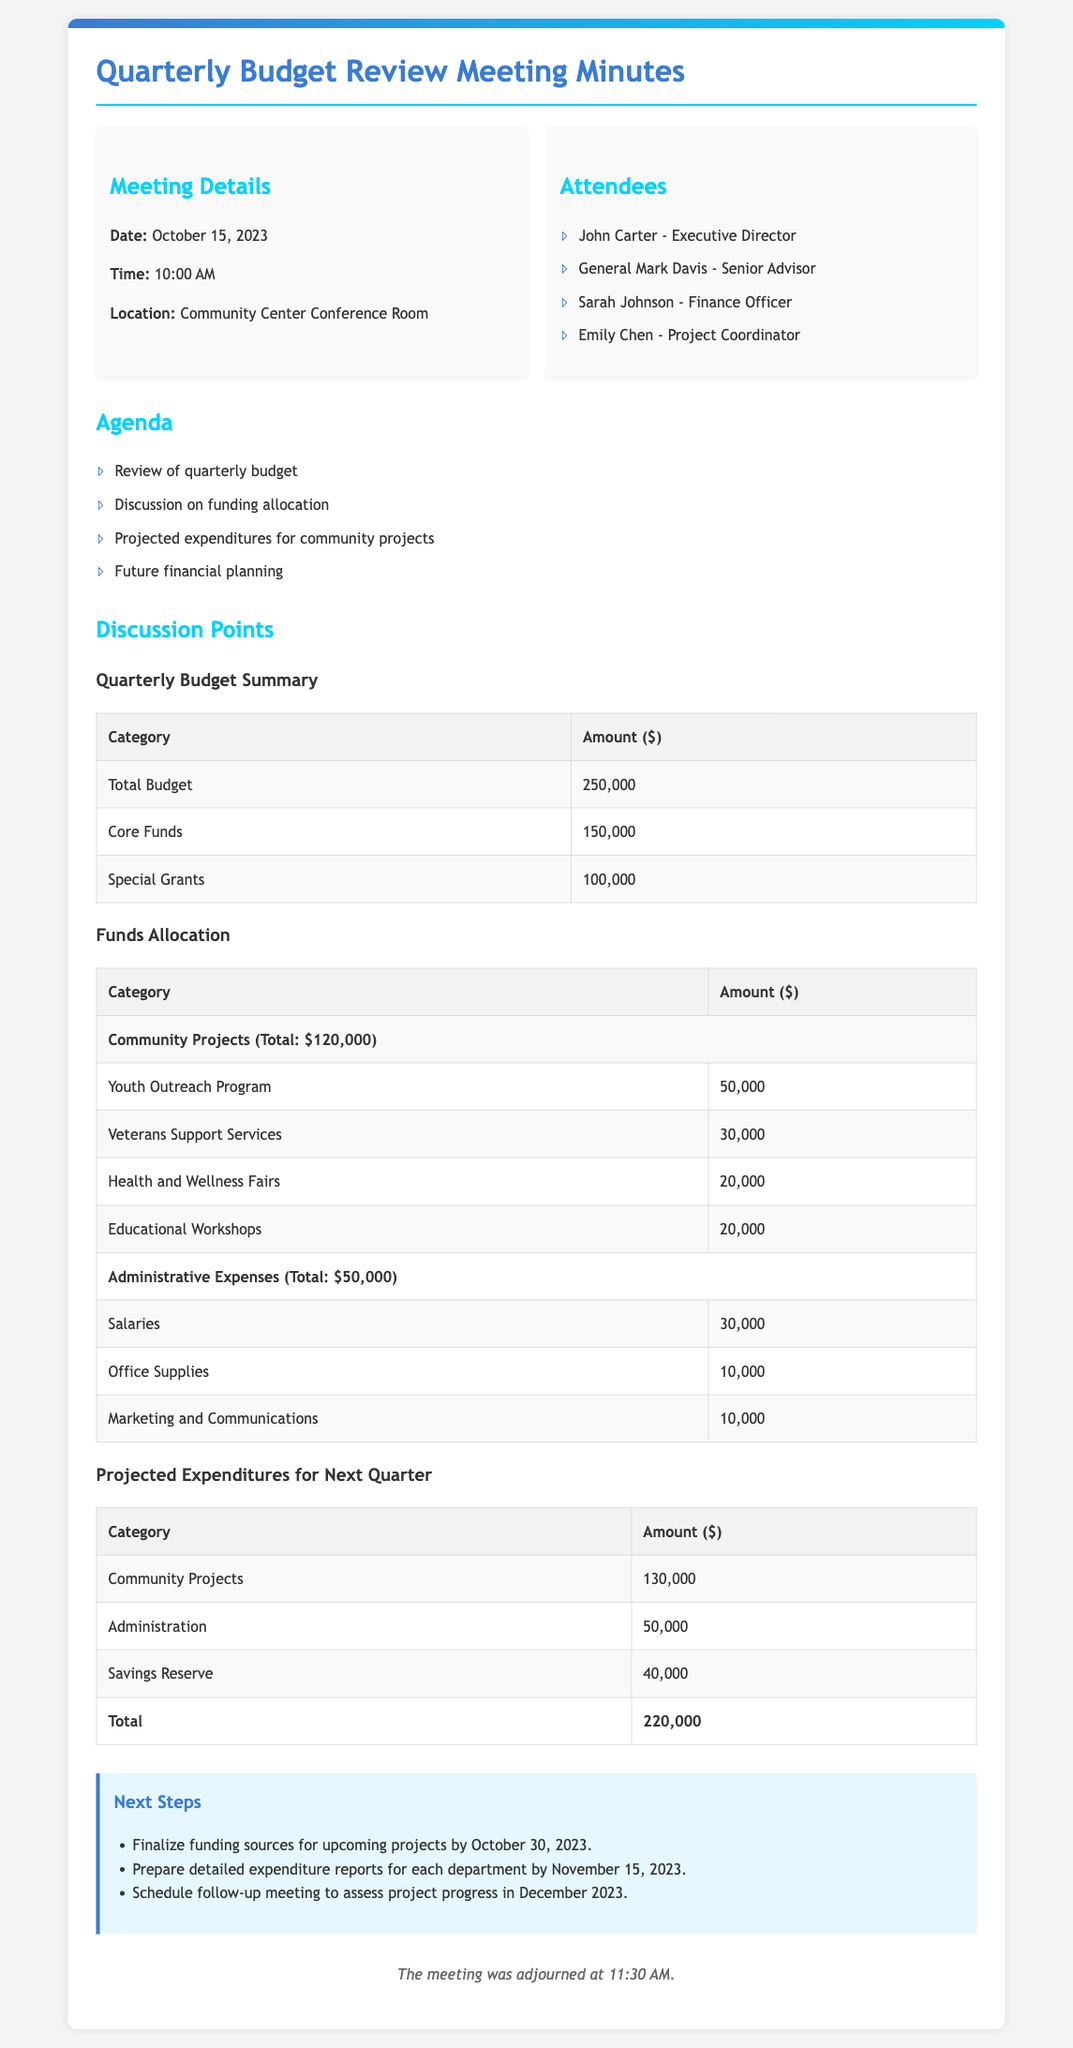What date was the meeting held? The date of the meeting can be found in the meeting details section of the document.
Answer: October 15, 2023 Who is the Executive Director? The name of the Executive Director is listed in the attendees section of the document.
Answer: John Carter What is the total budget amount? The total budget amount is provided in the quarterly budget summary table of the document.
Answer: 250,000 How much is allocated for Youth Outreach Program? The allocation for the Youth Outreach Program is detailed in the funds allocation table.
Answer: 50,000 What is the total projected expenditure for community projects next quarter? The total projected expenditure amount for community projects can be found in the projected expenditures table.
Answer: 130,000 How much is set aside for savings reserve? The amount set aside for savings reserve is included in the projected expenditures for next quarter.
Answer: 40,000 What total amount is allocated for administrative expenses? The total allocation for administrative expenses is summarized in the funds allocation table.
Answer: 50,000 What is the primary purpose of this meeting? The purpose of the meeting is indicated in the agenda section, which outlines the topics for discussion.
Answer: Quarterly budget review When is the deadline to finalize funding sources for upcoming projects? The deadline is mentioned in the next steps section of the document.
Answer: October 30, 2023 